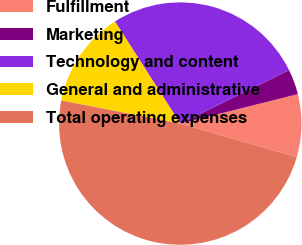Convert chart. <chart><loc_0><loc_0><loc_500><loc_500><pie_chart><fcel>Fulfillment<fcel>Marketing<fcel>Technology and content<fcel>General and administrative<fcel>Total operating expenses<nl><fcel>8.38%<fcel>3.35%<fcel>26.8%<fcel>12.9%<fcel>48.58%<nl></chart> 